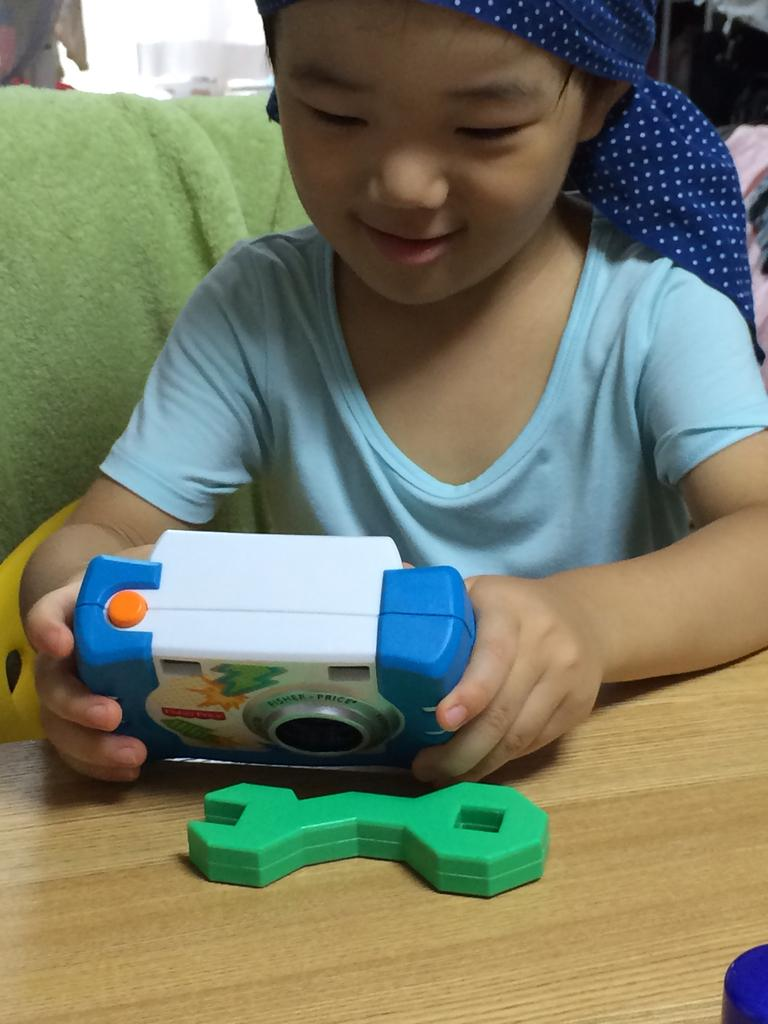What is the person in the image holding? The person is holding a toy in the image. Where are the toys located in the image? The toys are on a brown color surface in the image. What color is the cloth visible in the background of the image? The cloth in the background of the image is green. Can you describe any objects visible in the background of the image? Yes, there are objects visible in the background of the image. What type of berry is being served on a plate in the image? There is no berry or plate present in the image. Is there a maid visible in the image? There is no maid present in the image. 